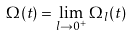Convert formula to latex. <formula><loc_0><loc_0><loc_500><loc_500>\Omega ( t ) = \lim _ { l \to 0 ^ { + } } \Omega _ { l } ( t )</formula> 